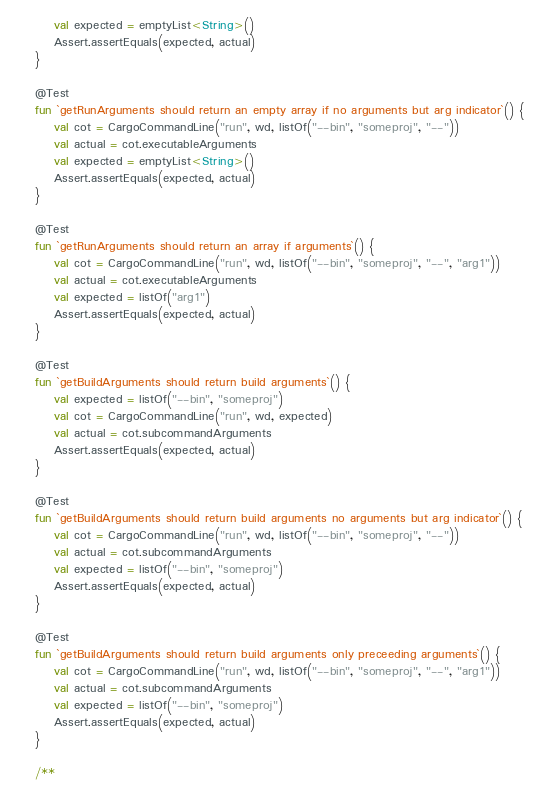<code> <loc_0><loc_0><loc_500><loc_500><_Kotlin_>        val expected = emptyList<String>()
        Assert.assertEquals(expected, actual)
    }

    @Test
    fun `getRunArguments should return an empty array if no arguments but arg indicator`() {
        val cot = CargoCommandLine("run", wd, listOf("--bin", "someproj", "--"))
        val actual = cot.executableArguments
        val expected = emptyList<String>()
        Assert.assertEquals(expected, actual)
    }

    @Test
    fun `getRunArguments should return an array if arguments`() {
        val cot = CargoCommandLine("run", wd, listOf("--bin", "someproj", "--", "arg1"))
        val actual = cot.executableArguments
        val expected = listOf("arg1")
        Assert.assertEquals(expected, actual)
    }

    @Test
    fun `getBuildArguments should return build arguments`() {
        val expected = listOf("--bin", "someproj")
        val cot = CargoCommandLine("run", wd, expected)
        val actual = cot.subcommandArguments
        Assert.assertEquals(expected, actual)
    }

    @Test
    fun `getBuildArguments should return build arguments no arguments but arg indicator`() {
        val cot = CargoCommandLine("run", wd, listOf("--bin", "someproj", "--"))
        val actual = cot.subcommandArguments
        val expected = listOf("--bin", "someproj")
        Assert.assertEquals(expected, actual)
    }

    @Test
    fun `getBuildArguments should return build arguments only preceeding arguments`() {
        val cot = CargoCommandLine("run", wd, listOf("--bin", "someproj", "--", "arg1"))
        val actual = cot.subcommandArguments
        val expected = listOf("--bin", "someproj")
        Assert.assertEquals(expected, actual)
    }

    /**</code> 